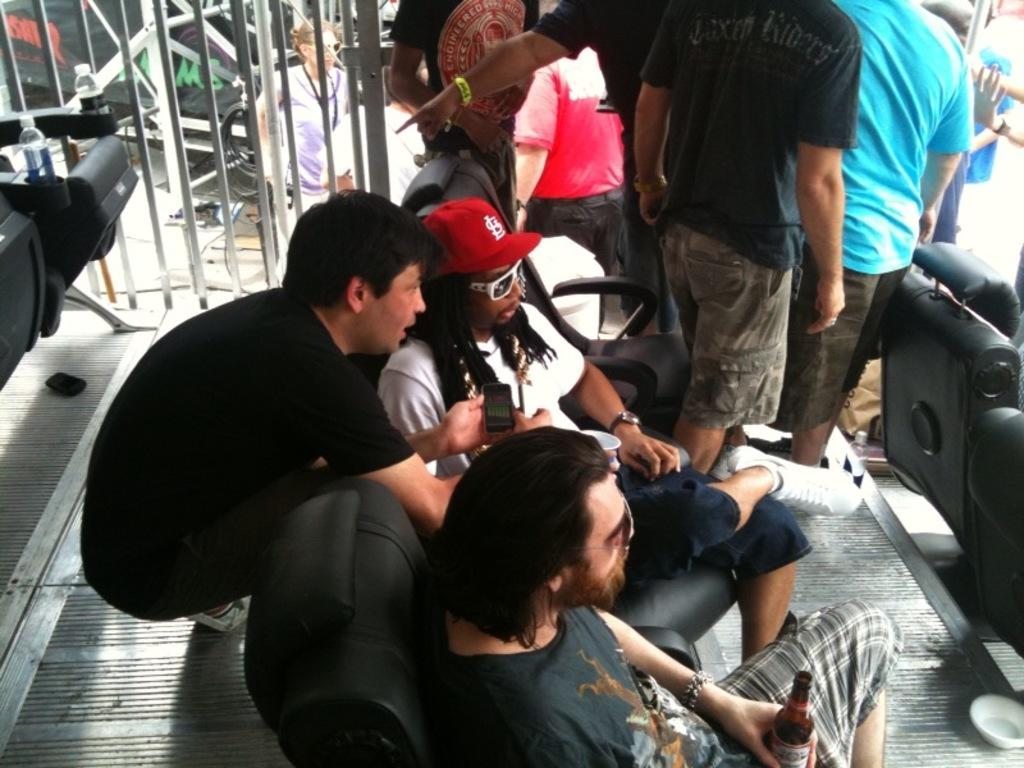How many people are sitting on chairs in the image? There are two people sitting on chairs in the image. What else can be seen in the image besides the people sitting on chairs? There are bottles visible in the image. Are there any people standing in the image? Yes, some people are standing in the image. What can be seen in the background of the image? There are objects in the background of the image. What type of sugar is being used to fuel the owl in the image? There is no owl or sugar present in the image. 